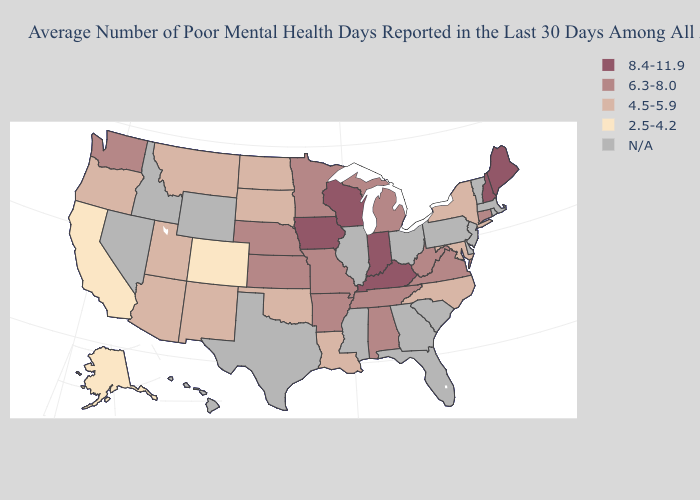How many symbols are there in the legend?
Write a very short answer. 5. Which states have the highest value in the USA?
Give a very brief answer. Indiana, Iowa, Kentucky, Maine, New Hampshire, Wisconsin. Among the states that border Wisconsin , which have the highest value?
Give a very brief answer. Iowa. Does the first symbol in the legend represent the smallest category?
Concise answer only. No. Among the states that border Wyoming , which have the highest value?
Short answer required. Nebraska. Which states have the lowest value in the USA?
Answer briefly. Alaska, California, Colorado. Which states have the lowest value in the USA?
Quick response, please. Alaska, California, Colorado. How many symbols are there in the legend?
Concise answer only. 5. What is the highest value in the USA?
Short answer required. 8.4-11.9. Is the legend a continuous bar?
Write a very short answer. No. What is the lowest value in the Northeast?
Quick response, please. 4.5-5.9. Name the states that have a value in the range 8.4-11.9?
Answer briefly. Indiana, Iowa, Kentucky, Maine, New Hampshire, Wisconsin. What is the lowest value in the MidWest?
Short answer required. 4.5-5.9. 